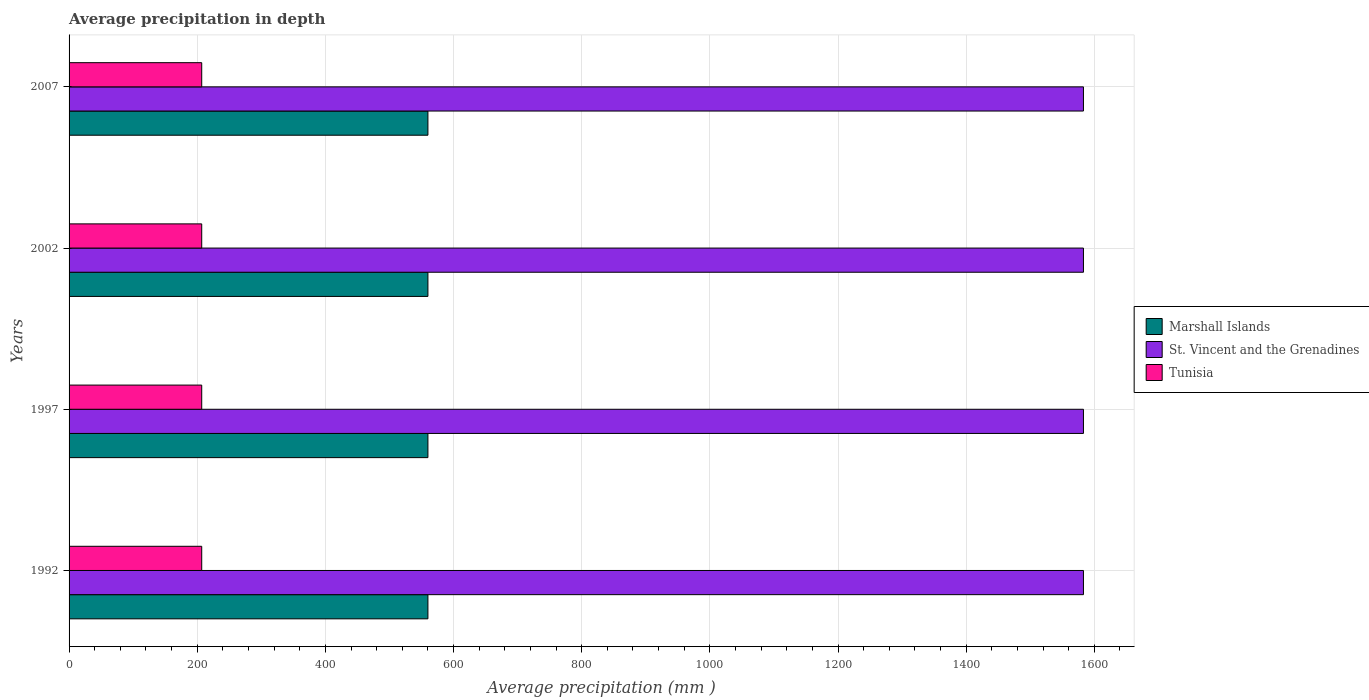How many different coloured bars are there?
Provide a succinct answer. 3. How many groups of bars are there?
Provide a short and direct response. 4. Are the number of bars on each tick of the Y-axis equal?
Your response must be concise. Yes. How many bars are there on the 2nd tick from the top?
Your response must be concise. 3. In how many cases, is the number of bars for a given year not equal to the number of legend labels?
Your answer should be very brief. 0. What is the average precipitation in Tunisia in 1992?
Keep it short and to the point. 207. Across all years, what is the maximum average precipitation in St. Vincent and the Grenadines?
Your answer should be very brief. 1583. Across all years, what is the minimum average precipitation in Marshall Islands?
Your response must be concise. 560. In which year was the average precipitation in Marshall Islands maximum?
Your response must be concise. 1992. What is the total average precipitation in Marshall Islands in the graph?
Offer a very short reply. 2240. What is the difference between the average precipitation in Tunisia in 1997 and that in 2002?
Your answer should be compact. 0. What is the difference between the average precipitation in St. Vincent and the Grenadines in 1992 and the average precipitation in Tunisia in 2002?
Provide a short and direct response. 1376. What is the average average precipitation in Marshall Islands per year?
Offer a terse response. 560. In the year 2002, what is the difference between the average precipitation in St. Vincent and the Grenadines and average precipitation in Tunisia?
Give a very brief answer. 1376. Is the difference between the average precipitation in St. Vincent and the Grenadines in 2002 and 2007 greater than the difference between the average precipitation in Tunisia in 2002 and 2007?
Offer a terse response. No. In how many years, is the average precipitation in St. Vincent and the Grenadines greater than the average average precipitation in St. Vincent and the Grenadines taken over all years?
Give a very brief answer. 0. What does the 2nd bar from the top in 1992 represents?
Provide a succinct answer. St. Vincent and the Grenadines. What does the 2nd bar from the bottom in 2007 represents?
Your answer should be very brief. St. Vincent and the Grenadines. How many bars are there?
Provide a succinct answer. 12. How many years are there in the graph?
Ensure brevity in your answer.  4. Are the values on the major ticks of X-axis written in scientific E-notation?
Offer a very short reply. No. Does the graph contain grids?
Offer a very short reply. Yes. How many legend labels are there?
Your answer should be very brief. 3. What is the title of the graph?
Make the answer very short. Average precipitation in depth. What is the label or title of the X-axis?
Provide a short and direct response. Average precipitation (mm ). What is the Average precipitation (mm ) of Marshall Islands in 1992?
Keep it short and to the point. 560. What is the Average precipitation (mm ) of St. Vincent and the Grenadines in 1992?
Your response must be concise. 1583. What is the Average precipitation (mm ) of Tunisia in 1992?
Keep it short and to the point. 207. What is the Average precipitation (mm ) in Marshall Islands in 1997?
Provide a short and direct response. 560. What is the Average precipitation (mm ) of St. Vincent and the Grenadines in 1997?
Provide a succinct answer. 1583. What is the Average precipitation (mm ) of Tunisia in 1997?
Ensure brevity in your answer.  207. What is the Average precipitation (mm ) of Marshall Islands in 2002?
Your answer should be very brief. 560. What is the Average precipitation (mm ) of St. Vincent and the Grenadines in 2002?
Make the answer very short. 1583. What is the Average precipitation (mm ) in Tunisia in 2002?
Make the answer very short. 207. What is the Average precipitation (mm ) of Marshall Islands in 2007?
Offer a terse response. 560. What is the Average precipitation (mm ) of St. Vincent and the Grenadines in 2007?
Give a very brief answer. 1583. What is the Average precipitation (mm ) of Tunisia in 2007?
Ensure brevity in your answer.  207. Across all years, what is the maximum Average precipitation (mm ) in Marshall Islands?
Your response must be concise. 560. Across all years, what is the maximum Average precipitation (mm ) in St. Vincent and the Grenadines?
Give a very brief answer. 1583. Across all years, what is the maximum Average precipitation (mm ) in Tunisia?
Make the answer very short. 207. Across all years, what is the minimum Average precipitation (mm ) in Marshall Islands?
Make the answer very short. 560. Across all years, what is the minimum Average precipitation (mm ) in St. Vincent and the Grenadines?
Ensure brevity in your answer.  1583. Across all years, what is the minimum Average precipitation (mm ) of Tunisia?
Offer a terse response. 207. What is the total Average precipitation (mm ) of Marshall Islands in the graph?
Provide a short and direct response. 2240. What is the total Average precipitation (mm ) in St. Vincent and the Grenadines in the graph?
Make the answer very short. 6332. What is the total Average precipitation (mm ) in Tunisia in the graph?
Keep it short and to the point. 828. What is the difference between the Average precipitation (mm ) of Tunisia in 1992 and that in 1997?
Keep it short and to the point. 0. What is the difference between the Average precipitation (mm ) in Marshall Islands in 1992 and that in 2002?
Provide a short and direct response. 0. What is the difference between the Average precipitation (mm ) of St. Vincent and the Grenadines in 1992 and that in 2002?
Make the answer very short. 0. What is the difference between the Average precipitation (mm ) of Tunisia in 1992 and that in 2002?
Offer a very short reply. 0. What is the difference between the Average precipitation (mm ) of Tunisia in 1992 and that in 2007?
Your response must be concise. 0. What is the difference between the Average precipitation (mm ) in Marshall Islands in 1997 and that in 2002?
Provide a short and direct response. 0. What is the difference between the Average precipitation (mm ) of Marshall Islands in 1997 and that in 2007?
Offer a very short reply. 0. What is the difference between the Average precipitation (mm ) in Tunisia in 1997 and that in 2007?
Offer a very short reply. 0. What is the difference between the Average precipitation (mm ) of Tunisia in 2002 and that in 2007?
Keep it short and to the point. 0. What is the difference between the Average precipitation (mm ) of Marshall Islands in 1992 and the Average precipitation (mm ) of St. Vincent and the Grenadines in 1997?
Your answer should be compact. -1023. What is the difference between the Average precipitation (mm ) in Marshall Islands in 1992 and the Average precipitation (mm ) in Tunisia in 1997?
Your answer should be very brief. 353. What is the difference between the Average precipitation (mm ) in St. Vincent and the Grenadines in 1992 and the Average precipitation (mm ) in Tunisia in 1997?
Keep it short and to the point. 1376. What is the difference between the Average precipitation (mm ) of Marshall Islands in 1992 and the Average precipitation (mm ) of St. Vincent and the Grenadines in 2002?
Give a very brief answer. -1023. What is the difference between the Average precipitation (mm ) of Marshall Islands in 1992 and the Average precipitation (mm ) of Tunisia in 2002?
Your answer should be compact. 353. What is the difference between the Average precipitation (mm ) of St. Vincent and the Grenadines in 1992 and the Average precipitation (mm ) of Tunisia in 2002?
Offer a terse response. 1376. What is the difference between the Average precipitation (mm ) in Marshall Islands in 1992 and the Average precipitation (mm ) in St. Vincent and the Grenadines in 2007?
Make the answer very short. -1023. What is the difference between the Average precipitation (mm ) of Marshall Islands in 1992 and the Average precipitation (mm ) of Tunisia in 2007?
Your response must be concise. 353. What is the difference between the Average precipitation (mm ) of St. Vincent and the Grenadines in 1992 and the Average precipitation (mm ) of Tunisia in 2007?
Your answer should be very brief. 1376. What is the difference between the Average precipitation (mm ) in Marshall Islands in 1997 and the Average precipitation (mm ) in St. Vincent and the Grenadines in 2002?
Give a very brief answer. -1023. What is the difference between the Average precipitation (mm ) in Marshall Islands in 1997 and the Average precipitation (mm ) in Tunisia in 2002?
Give a very brief answer. 353. What is the difference between the Average precipitation (mm ) of St. Vincent and the Grenadines in 1997 and the Average precipitation (mm ) of Tunisia in 2002?
Provide a succinct answer. 1376. What is the difference between the Average precipitation (mm ) of Marshall Islands in 1997 and the Average precipitation (mm ) of St. Vincent and the Grenadines in 2007?
Offer a very short reply. -1023. What is the difference between the Average precipitation (mm ) in Marshall Islands in 1997 and the Average precipitation (mm ) in Tunisia in 2007?
Provide a succinct answer. 353. What is the difference between the Average precipitation (mm ) of St. Vincent and the Grenadines in 1997 and the Average precipitation (mm ) of Tunisia in 2007?
Your response must be concise. 1376. What is the difference between the Average precipitation (mm ) of Marshall Islands in 2002 and the Average precipitation (mm ) of St. Vincent and the Grenadines in 2007?
Offer a terse response. -1023. What is the difference between the Average precipitation (mm ) in Marshall Islands in 2002 and the Average precipitation (mm ) in Tunisia in 2007?
Keep it short and to the point. 353. What is the difference between the Average precipitation (mm ) in St. Vincent and the Grenadines in 2002 and the Average precipitation (mm ) in Tunisia in 2007?
Your answer should be compact. 1376. What is the average Average precipitation (mm ) in Marshall Islands per year?
Make the answer very short. 560. What is the average Average precipitation (mm ) in St. Vincent and the Grenadines per year?
Provide a short and direct response. 1583. What is the average Average precipitation (mm ) of Tunisia per year?
Your response must be concise. 207. In the year 1992, what is the difference between the Average precipitation (mm ) of Marshall Islands and Average precipitation (mm ) of St. Vincent and the Grenadines?
Offer a terse response. -1023. In the year 1992, what is the difference between the Average precipitation (mm ) in Marshall Islands and Average precipitation (mm ) in Tunisia?
Your answer should be compact. 353. In the year 1992, what is the difference between the Average precipitation (mm ) in St. Vincent and the Grenadines and Average precipitation (mm ) in Tunisia?
Make the answer very short. 1376. In the year 1997, what is the difference between the Average precipitation (mm ) of Marshall Islands and Average precipitation (mm ) of St. Vincent and the Grenadines?
Your answer should be very brief. -1023. In the year 1997, what is the difference between the Average precipitation (mm ) in Marshall Islands and Average precipitation (mm ) in Tunisia?
Give a very brief answer. 353. In the year 1997, what is the difference between the Average precipitation (mm ) in St. Vincent and the Grenadines and Average precipitation (mm ) in Tunisia?
Offer a very short reply. 1376. In the year 2002, what is the difference between the Average precipitation (mm ) of Marshall Islands and Average precipitation (mm ) of St. Vincent and the Grenadines?
Keep it short and to the point. -1023. In the year 2002, what is the difference between the Average precipitation (mm ) in Marshall Islands and Average precipitation (mm ) in Tunisia?
Your answer should be compact. 353. In the year 2002, what is the difference between the Average precipitation (mm ) of St. Vincent and the Grenadines and Average precipitation (mm ) of Tunisia?
Your response must be concise. 1376. In the year 2007, what is the difference between the Average precipitation (mm ) in Marshall Islands and Average precipitation (mm ) in St. Vincent and the Grenadines?
Your response must be concise. -1023. In the year 2007, what is the difference between the Average precipitation (mm ) in Marshall Islands and Average precipitation (mm ) in Tunisia?
Your response must be concise. 353. In the year 2007, what is the difference between the Average precipitation (mm ) of St. Vincent and the Grenadines and Average precipitation (mm ) of Tunisia?
Keep it short and to the point. 1376. What is the ratio of the Average precipitation (mm ) in St. Vincent and the Grenadines in 1992 to that in 1997?
Your response must be concise. 1. What is the ratio of the Average precipitation (mm ) of Marshall Islands in 1992 to that in 2002?
Your answer should be compact. 1. What is the ratio of the Average precipitation (mm ) in St. Vincent and the Grenadines in 1992 to that in 2007?
Provide a short and direct response. 1. What is the ratio of the Average precipitation (mm ) of Tunisia in 1992 to that in 2007?
Your answer should be compact. 1. What is the ratio of the Average precipitation (mm ) of Marshall Islands in 1997 to that in 2002?
Give a very brief answer. 1. What is the ratio of the Average precipitation (mm ) in St. Vincent and the Grenadines in 1997 to that in 2002?
Keep it short and to the point. 1. What is the ratio of the Average precipitation (mm ) in St. Vincent and the Grenadines in 1997 to that in 2007?
Your response must be concise. 1. What is the ratio of the Average precipitation (mm ) of Tunisia in 1997 to that in 2007?
Ensure brevity in your answer.  1. What is the difference between the highest and the lowest Average precipitation (mm ) of St. Vincent and the Grenadines?
Provide a succinct answer. 0. What is the difference between the highest and the lowest Average precipitation (mm ) of Tunisia?
Your answer should be compact. 0. 